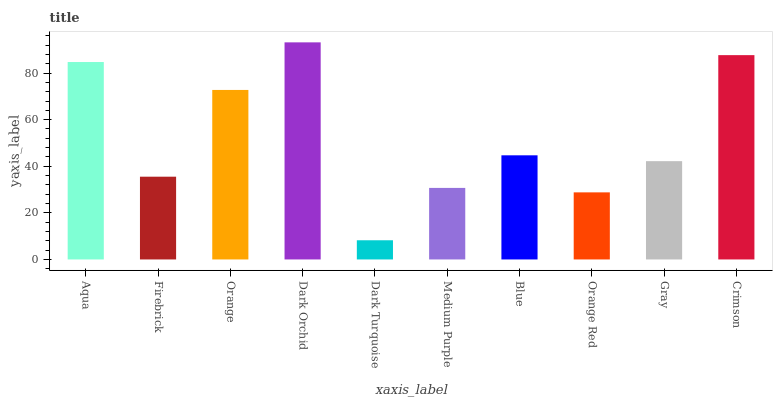Is Dark Turquoise the minimum?
Answer yes or no. Yes. Is Dark Orchid the maximum?
Answer yes or no. Yes. Is Firebrick the minimum?
Answer yes or no. No. Is Firebrick the maximum?
Answer yes or no. No. Is Aqua greater than Firebrick?
Answer yes or no. Yes. Is Firebrick less than Aqua?
Answer yes or no. Yes. Is Firebrick greater than Aqua?
Answer yes or no. No. Is Aqua less than Firebrick?
Answer yes or no. No. Is Blue the high median?
Answer yes or no. Yes. Is Gray the low median?
Answer yes or no. Yes. Is Firebrick the high median?
Answer yes or no. No. Is Orange the low median?
Answer yes or no. No. 